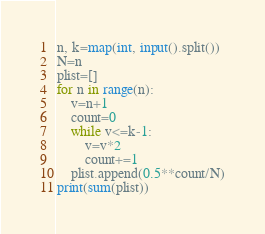Convert code to text. <code><loc_0><loc_0><loc_500><loc_500><_Python_>n, k=map(int, input().split())
N=n
plist=[]
for n in range(n):
    v=n+1
    count=0
    while v<=k-1:
        v=v*2
        count+=1
    plist.append(0.5**count/N)
print(sum(plist))</code> 